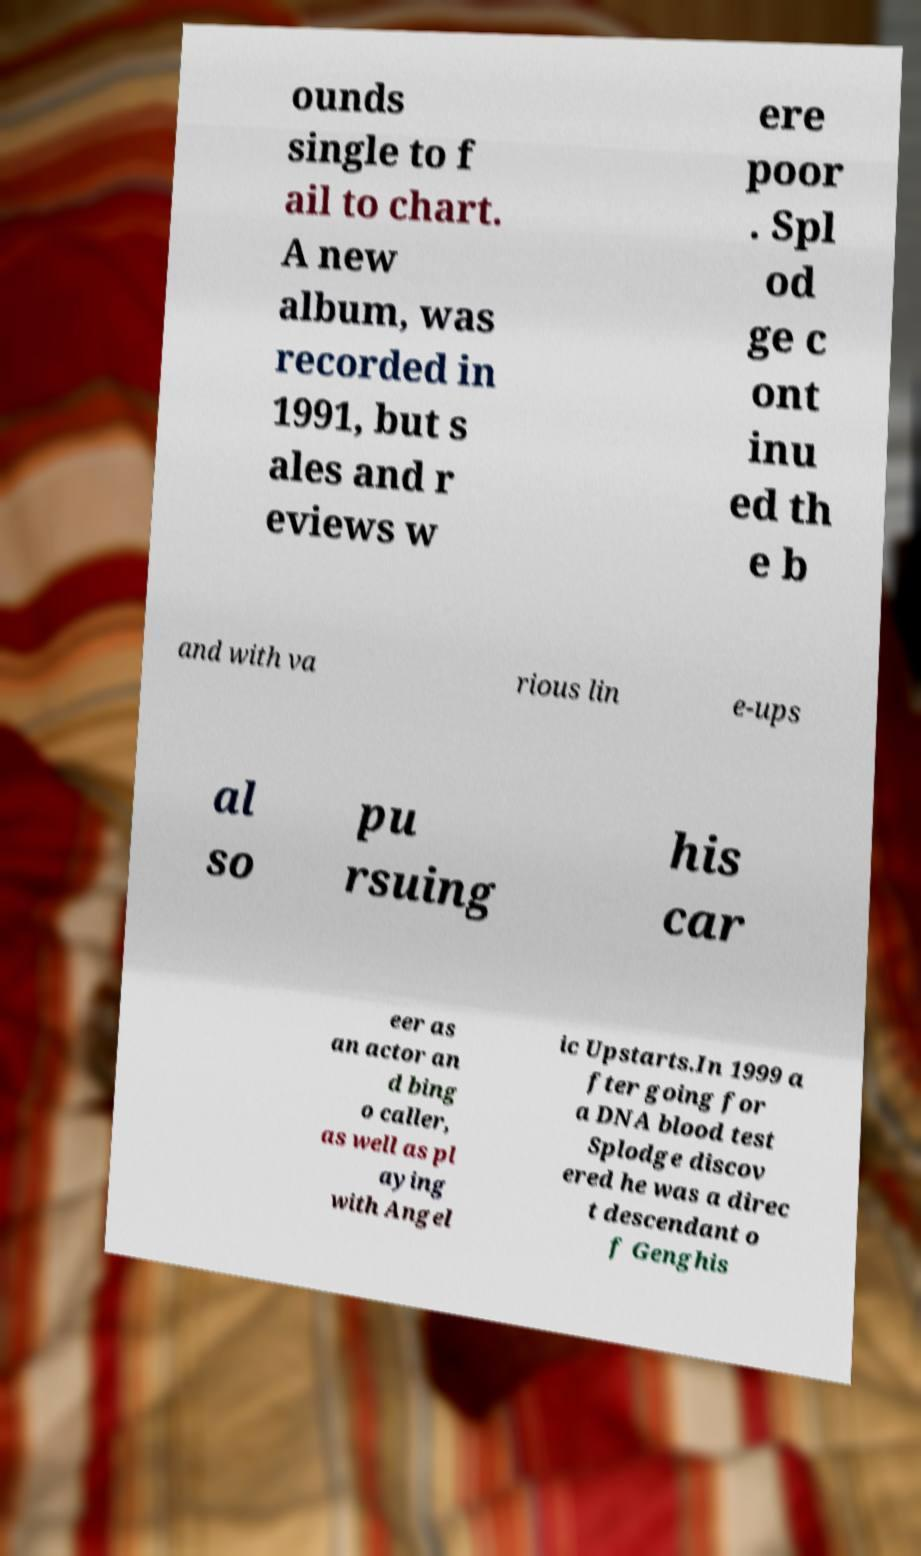Can you read and provide the text displayed in the image?This photo seems to have some interesting text. Can you extract and type it out for me? ounds single to f ail to chart. A new album, was recorded in 1991, but s ales and r eviews w ere poor . Spl od ge c ont inu ed th e b and with va rious lin e-ups al so pu rsuing his car eer as an actor an d bing o caller, as well as pl aying with Angel ic Upstarts.In 1999 a fter going for a DNA blood test Splodge discov ered he was a direc t descendant o f Genghis 